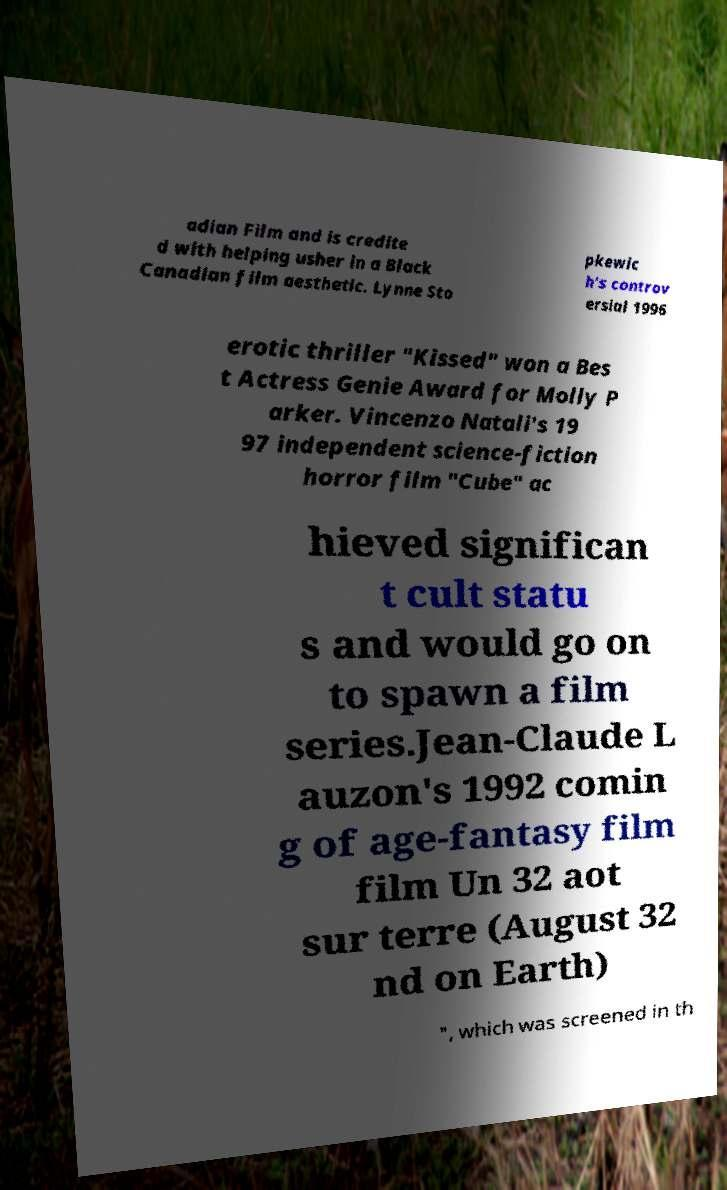Please identify and transcribe the text found in this image. adian Film and is credite d with helping usher in a Black Canadian film aesthetic. Lynne Sto pkewic h's controv ersial 1996 erotic thriller "Kissed" won a Bes t Actress Genie Award for Molly P arker. Vincenzo Natali's 19 97 independent science-fiction horror film "Cube" ac hieved significan t cult statu s and would go on to spawn a film series.Jean-Claude L auzon's 1992 comin g of age-fantasy film film Un 32 aot sur terre (August 32 nd on Earth) ", which was screened in th 